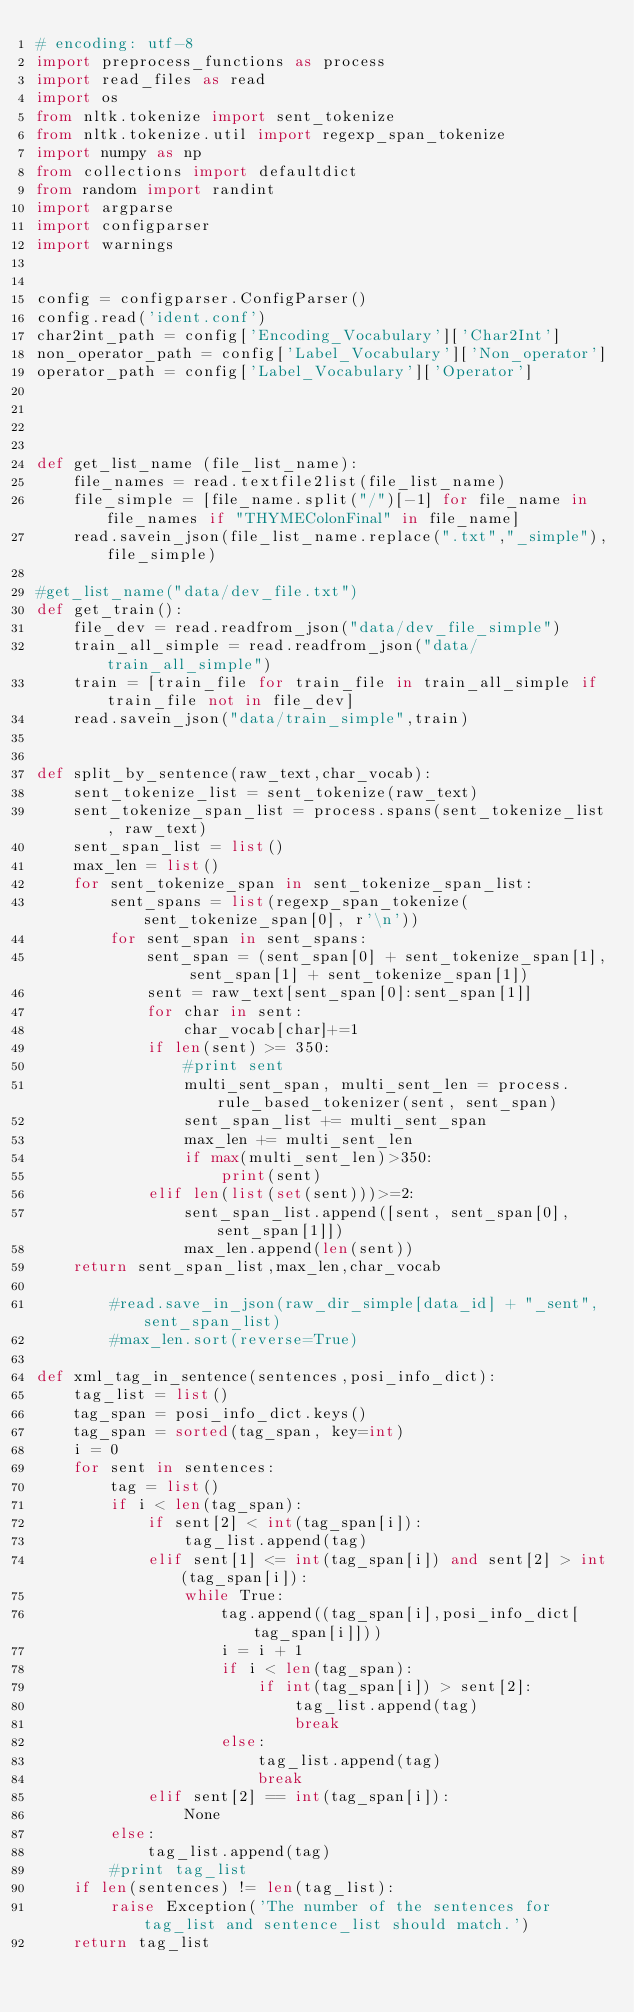<code> <loc_0><loc_0><loc_500><loc_500><_Python_># encoding: utf-8
import preprocess_functions as process
import read_files as read
import os
from nltk.tokenize import sent_tokenize
from nltk.tokenize.util import regexp_span_tokenize
import numpy as np
from collections import defaultdict
from random import randint
import argparse
import configparser
import warnings


config = configparser.ConfigParser()
config.read('ident.conf')
char2int_path = config['Encoding_Vocabulary']['Char2Int']
non_operator_path = config['Label_Vocabulary']['Non_operator']
operator_path = config['Label_Vocabulary']['Operator']




def get_list_name (file_list_name):
    file_names = read.textfile2list(file_list_name)
    file_simple = [file_name.split("/")[-1] for file_name in file_names if "THYMEColonFinal" in file_name]
    read.savein_json(file_list_name.replace(".txt","_simple"),file_simple)

#get_list_name("data/dev_file.txt")
def get_train():
    file_dev = read.readfrom_json("data/dev_file_simple")
    train_all_simple = read.readfrom_json("data/train_all_simple")
    train = [train_file for train_file in train_all_simple if train_file not in file_dev]
    read.savein_json("data/train_simple",train)


def split_by_sentence(raw_text,char_vocab):
    sent_tokenize_list = sent_tokenize(raw_text)
    sent_tokenize_span_list = process.spans(sent_tokenize_list, raw_text)
    sent_span_list = list()
    max_len = list()
    for sent_tokenize_span in sent_tokenize_span_list:
        sent_spans = list(regexp_span_tokenize(sent_tokenize_span[0], r'\n'))
        for sent_span in sent_spans:
            sent_span = (sent_span[0] + sent_tokenize_span[1], sent_span[1] + sent_tokenize_span[1])
            sent = raw_text[sent_span[0]:sent_span[1]]
            for char in sent:
                char_vocab[char]+=1
            if len(sent) >= 350:
                #print sent
                multi_sent_span, multi_sent_len = process.rule_based_tokenizer(sent, sent_span)
                sent_span_list += multi_sent_span
                max_len += multi_sent_len
                if max(multi_sent_len)>350:
                    print(sent)
            elif len(list(set(sent)))>=2:
                sent_span_list.append([sent, sent_span[0], sent_span[1]])
                max_len.append(len(sent))
    return sent_span_list,max_len,char_vocab

        #read.save_in_json(raw_dir_simple[data_id] + "_sent", sent_span_list)
        #max_len.sort(reverse=True)

def xml_tag_in_sentence(sentences,posi_info_dict):
    tag_list = list()
    tag_span = posi_info_dict.keys()
    tag_span = sorted(tag_span, key=int)
    i = 0
    for sent in sentences:
        tag = list()
        if i < len(tag_span):
            if sent[2] < int(tag_span[i]):
                tag_list.append(tag)
            elif sent[1] <= int(tag_span[i]) and sent[2] > int(tag_span[i]):
                while True:
                    tag.append((tag_span[i],posi_info_dict[tag_span[i]]))
                    i = i + 1
                    if i < len(tag_span):
                        if int(tag_span[i]) > sent[2]:
                            tag_list.append(tag)
                            break
                    else:
                        tag_list.append(tag)
                        break
            elif sent[2] == int(tag_span[i]):
                None
        else:
            tag_list.append(tag)
        #print tag_list
    if len(sentences) != len(tag_list):
        raise Exception('The number of the sentences for tag_list and sentence_list should match.')
    return tag_list
</code> 